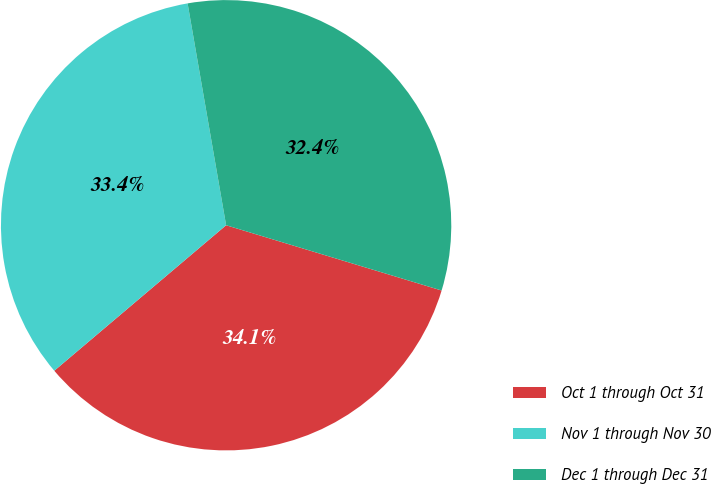Convert chart. <chart><loc_0><loc_0><loc_500><loc_500><pie_chart><fcel>Oct 1 through Oct 31<fcel>Nov 1 through Nov 30<fcel>Dec 1 through Dec 31<nl><fcel>34.14%<fcel>33.45%<fcel>32.42%<nl></chart> 